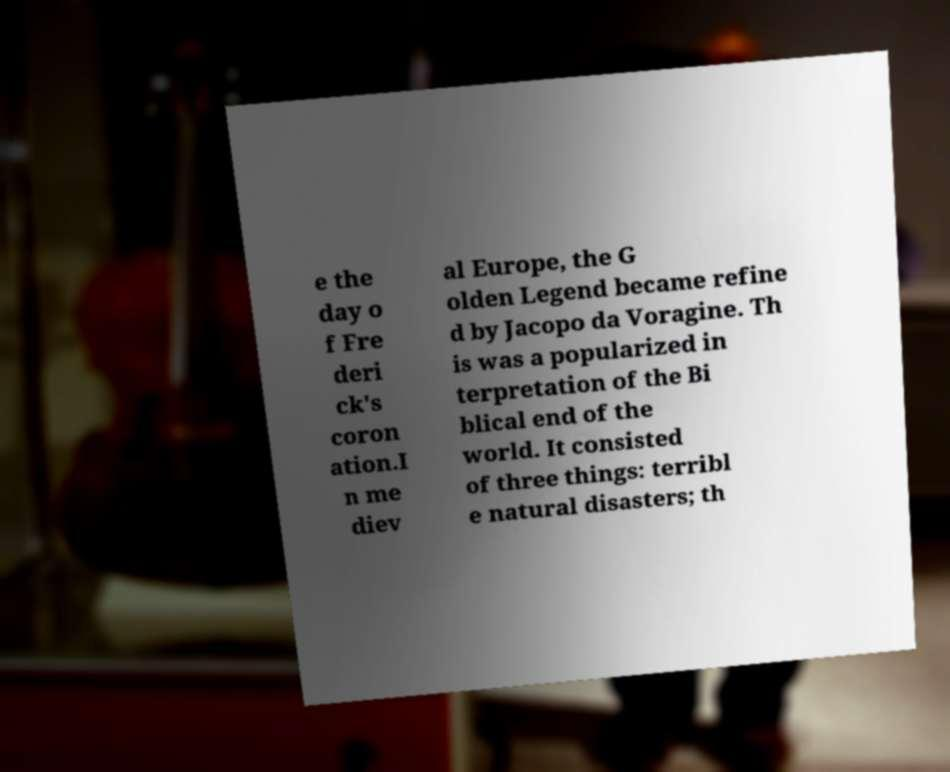Could you assist in decoding the text presented in this image and type it out clearly? e the day o f Fre deri ck's coron ation.I n me diev al Europe, the G olden Legend became refine d by Jacopo da Voragine. Th is was a popularized in terpretation of the Bi blical end of the world. It consisted of three things: terribl e natural disasters; th 